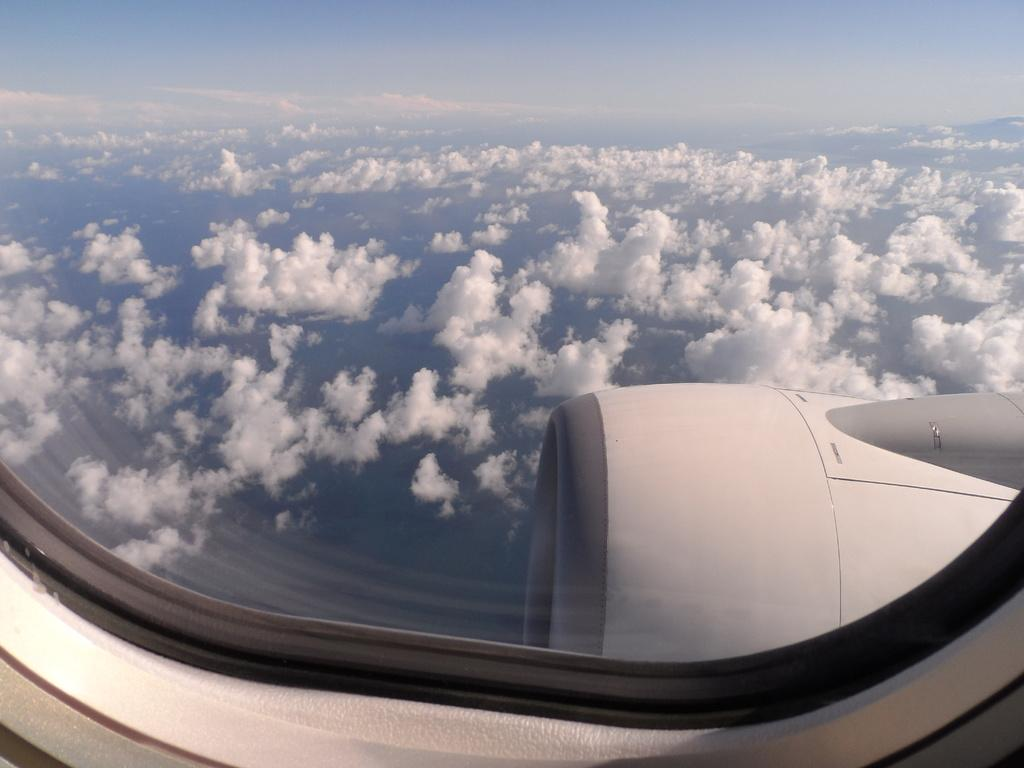What is the location of the person taking the image? The image is taken from inside an airplane. What can be seen outside the airplane in the image? Clouds and the sky are visible in the image. What part of the airplane is visible in the image? The wing of an airplane is visible in the image. Can you tell me how many tigers are visible in the image? There are no tigers present in the image; it features clouds, sky, and an airplane wing. What type of science experiment is being conducted in the image? There is no science experiment visible in the image; it is a view from inside an airplane. 